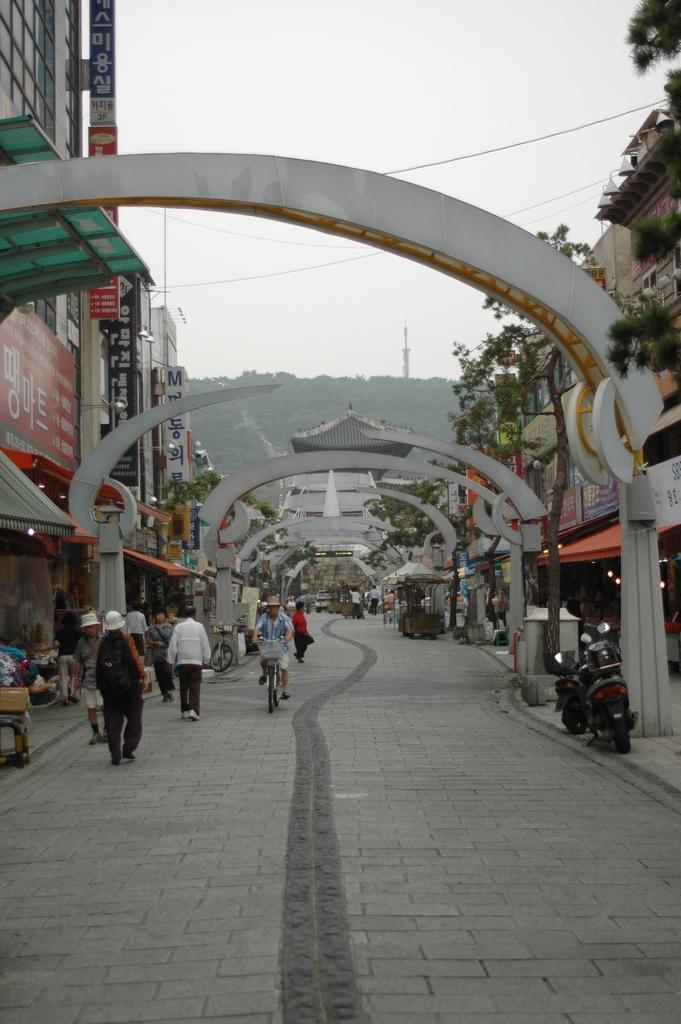What is the main subject of the image? There is a person riding a bicycle in the image. What other vehicles are present in the image? There are motorbikes in the image. Can you describe the people in the image? There is a group of people standing in the image. What type of structures can be seen in the image? There are buildings, boards, arches, and a tower in the image. What additional features are present in the image? There are lights, trees, and a hill in the image. What is visible in the background of the image? The sky is visible in the image. What type of quill is being used by the person riding the bicycle in the image? There is no quill present in the image; the person is riding a bicycle. How does the stomach of the person riding the bicycle appear in the image? There is no indication of the person's stomach in the image, as the focus is on the bicycle and not the person's body. 